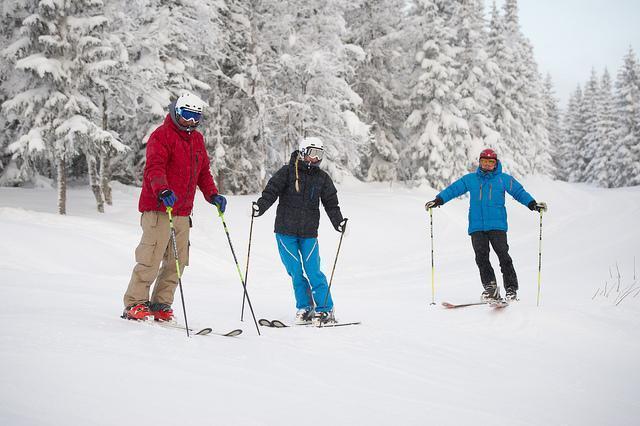How many people have pants and coat that are the same color?
Give a very brief answer. 0. How many people can you see?
Give a very brief answer. 3. How many dolphins are painted on the boats in this photo?
Give a very brief answer. 0. 